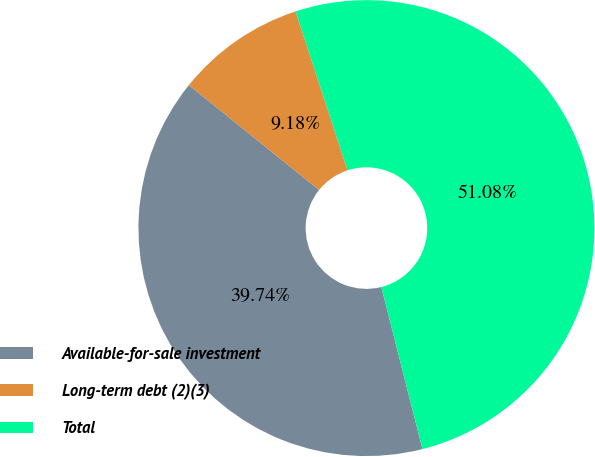Convert chart to OTSL. <chart><loc_0><loc_0><loc_500><loc_500><pie_chart><fcel>Available-for-sale investment<fcel>Long-term debt (2)(3)<fcel>Total<nl><fcel>39.74%<fcel>9.18%<fcel>51.08%<nl></chart> 